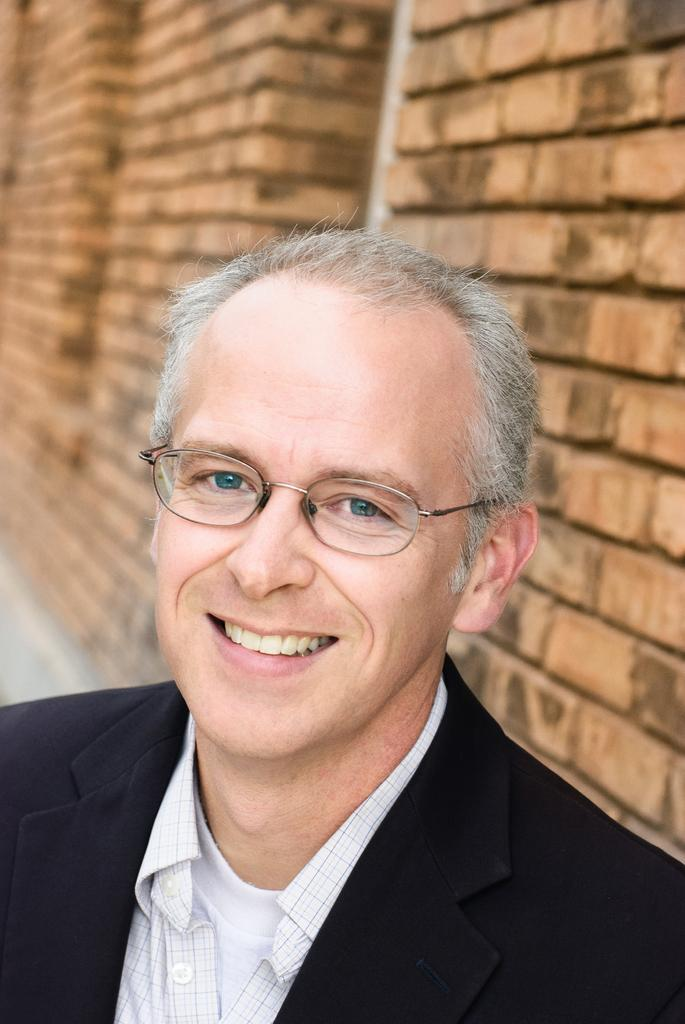What is the main subject of the image? There is a person in the image. What is the person wearing? The person is wearing a black suit. What is the person's facial expression? The person is smiling. What can be seen in the background of the image? There is a brick wall in the background of the image. What type of shoe is the person wearing in the image? The provided facts do not mention any shoes, so we cannot determine the type of shoe the person is wearing. 